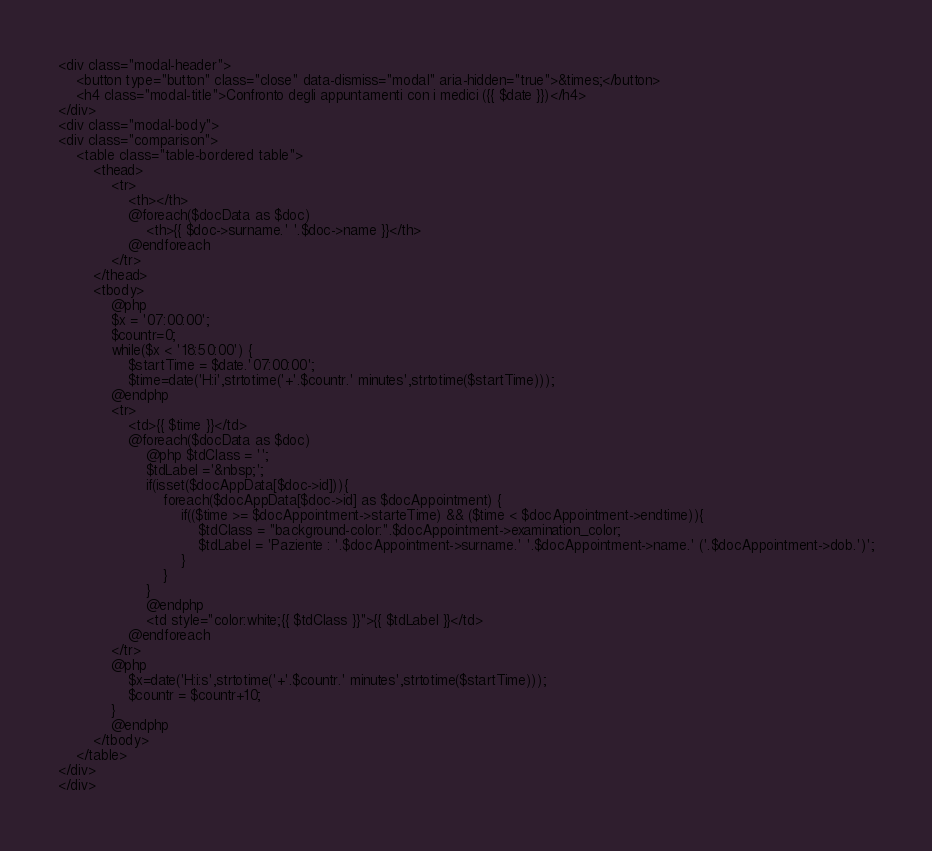<code> <loc_0><loc_0><loc_500><loc_500><_PHP_><div class="modal-header">
    <button type="button" class="close" data-dismiss="modal" aria-hidden="true">&times;</button>
    <h4 class="modal-title">Confronto degli appuntamenti con i medici ({{ $date }})</h4>
</div>
<div class="modal-body">
<div class="comparison">
	<table class="table-bordered table">
		<thead>
			<tr>
				<th></th>
	        	@foreach($docData as $doc)
	           		<th>{{ $doc->surname.' '.$doc->name }}</th>
	        	@endforeach
		    </tr>
		</thead>
		<tbody>
			@php
			$x = '07:00:00';
			$countr=0;
			while($x < '18:50:00') {
				$startTime = $date.'07:00:00';
			    $time=date('H:i',strtotime('+'.$countr.' minutes',strtotime($startTime)));
			@endphp
			<tr>
				<td>{{ $time }}</td>
				@foreach($docData as $doc)
					@php $tdClass = '';
					$tdLabel ='&nbsp;';
					if(isset($docAppData[$doc->id])){
						foreach($docAppData[$doc->id] as $docAppointment) {
							if(($time >= $docAppointment->starteTime) && ($time < $docAppointment->endtime)){
								$tdClass = "background-color:".$docAppointment->examination_color;
								$tdLabel = 'Paziente : '.$docAppointment->surname.' '.$docAppointment->name.' ('.$docAppointment->dob.')';
							}
						}
					}
					@endphp
					<td style="color:white;{{ $tdClass }}">{{ $tdLabel }}</td>
				@endforeach
			</tr>
			@php
				$x=date('H:i:s',strtotime('+'.$countr.' minutes',strtotime($startTime)));
				$countr = $countr+10;
			}
			@endphp
		</tbody>
	</table>
</div>
</div></code> 